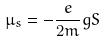Convert formula to latex. <formula><loc_0><loc_0><loc_500><loc_500>\mu _ { s } = - \frac { e } { 2 m } g S</formula> 